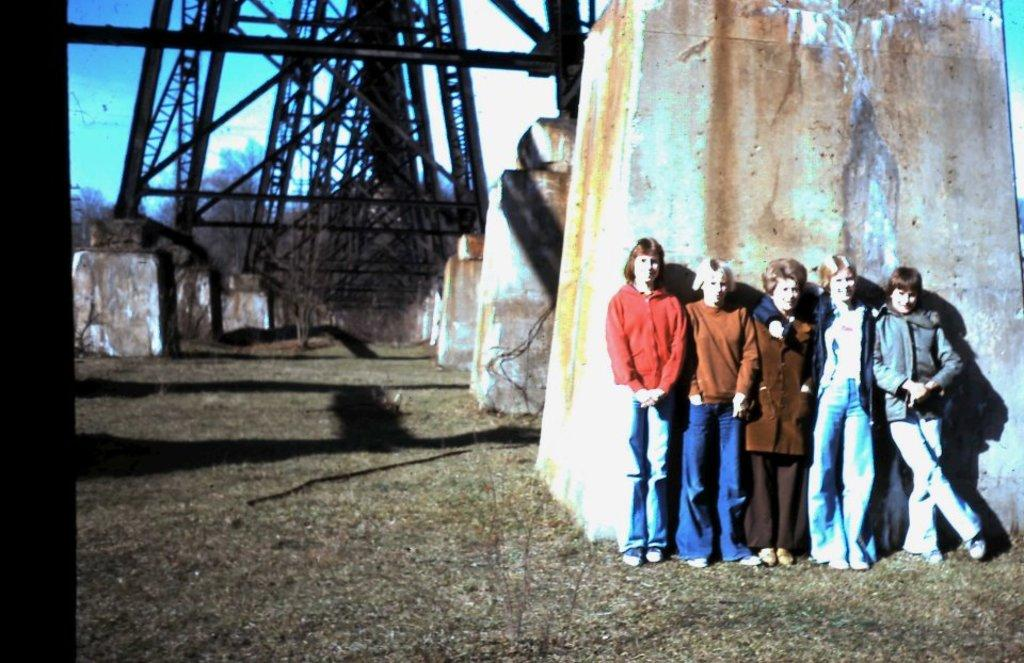What is the main subject of the image? The main subject of the image is a group of women. Where are the women located in the image? The women are standing on the ground. What can be seen in the background of the image? In the background of the image, there are metal frames placed on concrete surfaces and a group of trees. What is visible at the top of the image? The sky is visible in the background of the image. What is the name of the cast member who plays the side character in the image? There is no cast or side character in the image, as it features a group of women standing on the ground with a background of metal frames, trees, and the sky. 